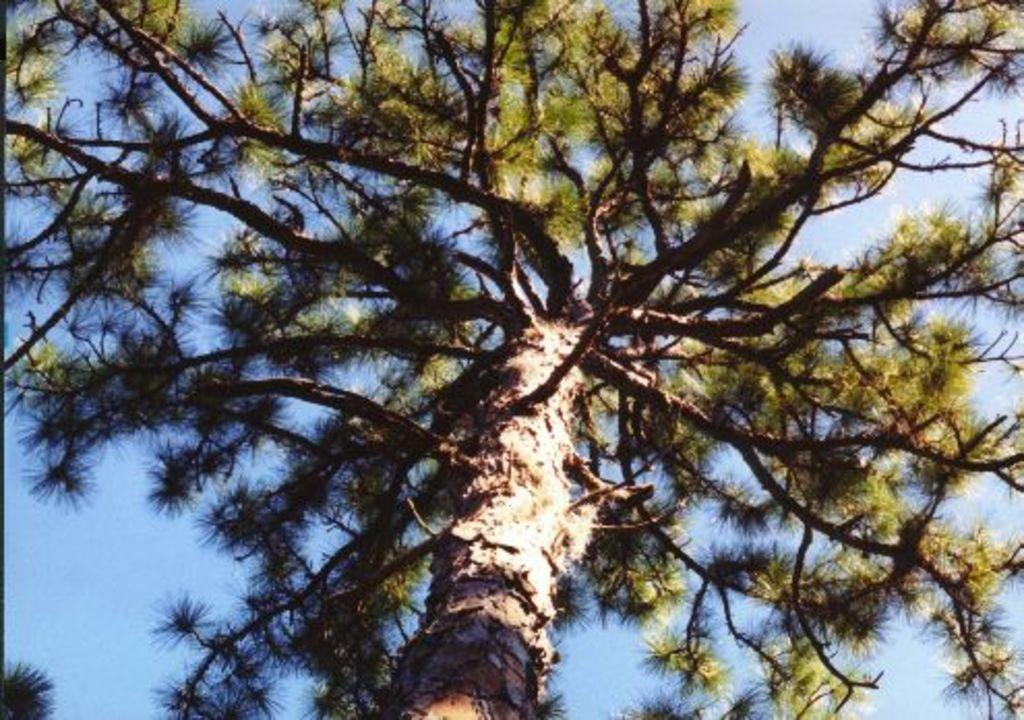What is present in the image? There is a tree in the image. What is the condition of the tree's leaves? The tree has green leaves. What can be seen in the background of the image? There is sky visible in the background of the image. How many grapes are hanging from the tree in the image? There are no grapes present in the image; it features a tree with green leaves. What is the aftermath of the storm in the image? There is no mention of a storm or any aftermath in the image; it only shows a tree with green leaves and sky in the background. 